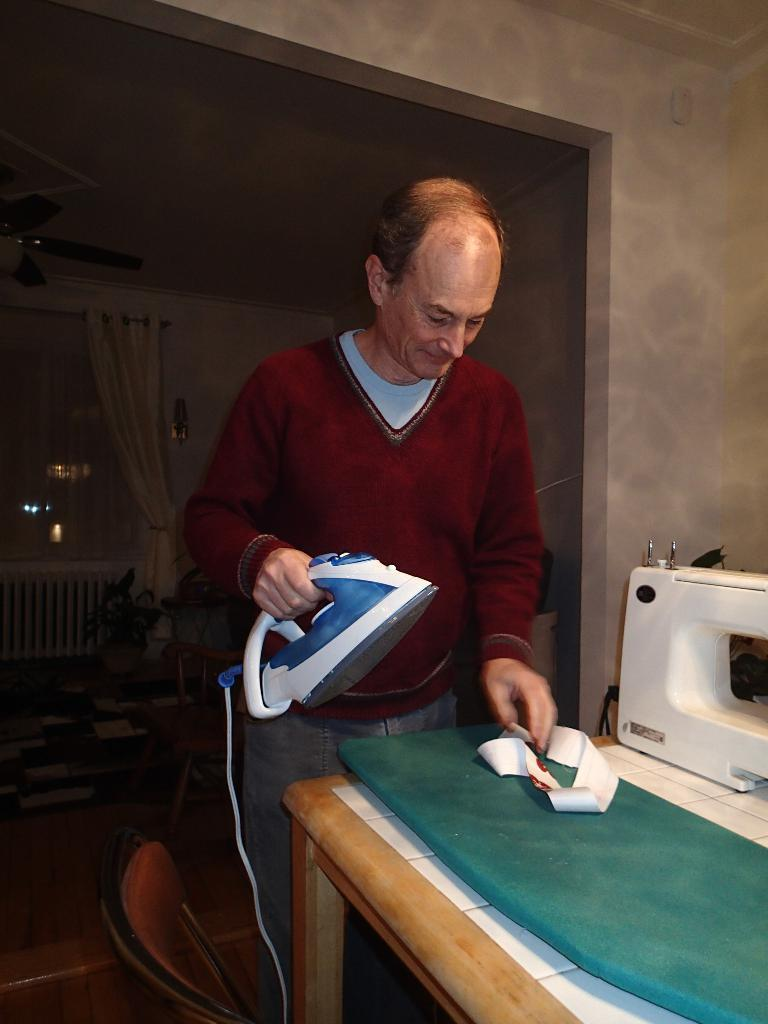What type of structure can be seen in the image? There is a wall in the image. What is hanging near the wall? There is a curtain in the image. What is a feature of the wall that allows light to enter the room? There is a window in the image. What piece of furniture is present in the room? There is a table in the image. What type of equipment is visible in the image? There is a sewing machine in the image. What is the person holding in the image? There is a person holding an iron box in the image. What color is the brain on the table in the image? There is no brain present in the image; it features a wall, curtain, window, table, sewing machine, and a person holding an iron box. How many rolls of fabric are visible on the table in the image? There is no mention of rolls of fabric in the image; it only features a sewing machine and an iron box. 